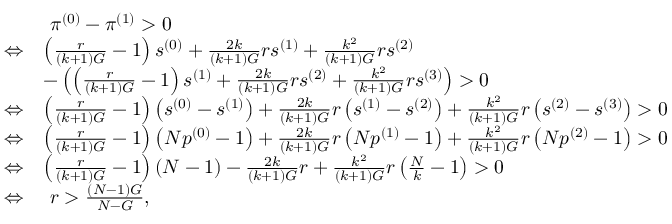<formula> <loc_0><loc_0><loc_500><loc_500>\begin{array} { r l } & { \pi ^ { ( 0 ) } - \pi ^ { ( 1 ) } > 0 } \\ { \Leftrightarrow } & { \left ( \frac { r } { ( k + 1 ) G } - 1 \right ) s ^ { ( 0 ) } + \frac { 2 k } { ( k + 1 ) G } r s ^ { ( 1 ) } + \frac { k ^ { 2 } } { ( k + 1 ) G } r s ^ { ( 2 ) } } \\ & { - \left ( \left ( \frac { r } { ( k + 1 ) G } - 1 \right ) s ^ { ( 1 ) } + \frac { 2 k } { ( k + 1 ) G } r s ^ { ( 2 ) } + \frac { k ^ { 2 } } { ( k + 1 ) G } r s ^ { ( 3 ) } \right ) > 0 } \\ { \Leftrightarrow } & { \left ( \frac { r } { ( k + 1 ) G } - 1 \right ) \left ( s ^ { ( 0 ) } - s ^ { ( 1 ) } \right ) + \frac { 2 k } { ( k + 1 ) G } r \left ( s ^ { ( 1 ) } - s ^ { ( 2 ) } \right ) + \frac { k ^ { 2 } } { ( k + 1 ) G } r \left ( s ^ { ( 2 ) } - s ^ { ( 3 ) } \right ) > 0 } \\ { \Leftrightarrow } & { \left ( \frac { r } { ( k + 1 ) G } - 1 \right ) \left ( N p ^ { ( 0 ) } - 1 \right ) + \frac { 2 k } { ( k + 1 ) G } r \left ( N p ^ { ( 1 ) } - 1 \right ) + \frac { k ^ { 2 } } { ( k + 1 ) G } r \left ( N p ^ { ( 2 ) } - 1 \right ) > 0 } \\ { \Leftrightarrow } & { \left ( \frac { r } { ( k + 1 ) G } - 1 \right ) \left ( N - 1 \right ) - \frac { 2 k } { ( k + 1 ) G } r + \frac { k ^ { 2 } } { ( k + 1 ) G } r \left ( \frac { N } { k } - 1 \right ) > 0 } \\ { \Leftrightarrow } & { r > \frac { ( N - 1 ) G } { N - G } , } \end{array}</formula> 